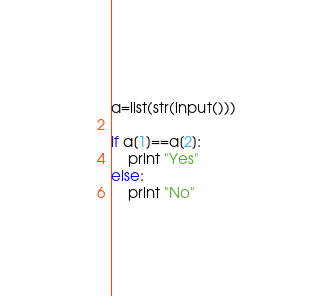<code> <loc_0><loc_0><loc_500><loc_500><_Python_>a=list(str(input()))

if a[1]==a[2]:
    print "Yes"
else:
    print "No"</code> 